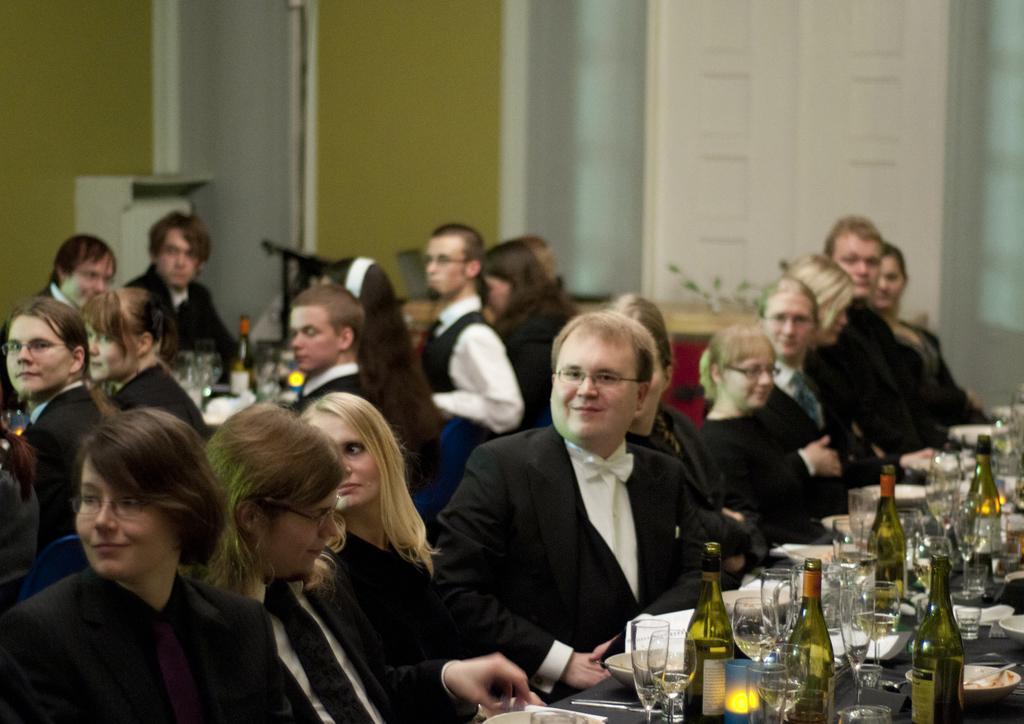In one or two sentences, can you explain what this image depicts? In this image I can see number of people are sitting on chairs. I can see everyone are wearing formal dress and few of them are wearing specs. I can also see few bottles, number of glasses, number of plates and few bowls. I can also see this image is little bit blurry from background. 